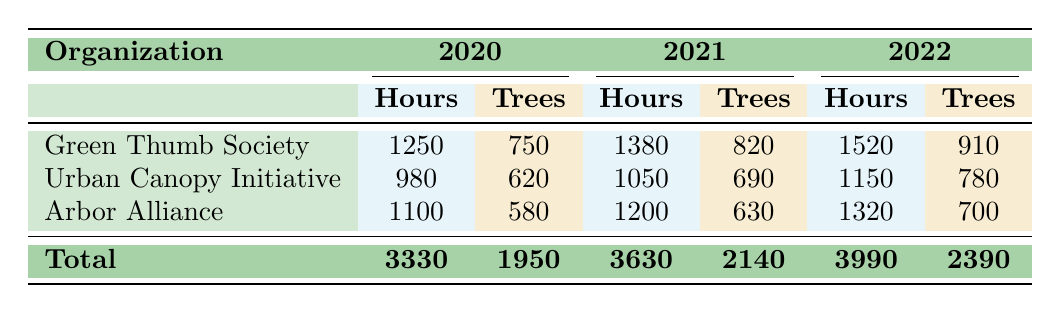What was the total number of volunteer hours recorded in 2020? By adding the volunteer hours from each organization in 2020: Green Thumb Society (1250) + Urban Canopy Initiative (980) + Arbor Alliance (1100) = 3330 hours.
Answer: 3330 How many trees were planted by the Urban Canopy Initiative in 2021? The table shows that the Urban Canopy Initiative planted 690 trees in 2021.
Answer: 690 Which organization had the highest number of volunteer hours in 2022? Green Thumb Society had 1520 volunteer hours in 2022, which is higher than Urban Canopy Initiative (1150) and Arbor Alliance (1320).
Answer: Green Thumb Society What is the average number of trees planted per organization in 2020? In 2020, there were three organizations (Green Thumb Society, Urban Canopy Initiative, Arbor Alliance) that planted a total of 1950 trees. To find the average, divide 1950 by 3, which equals 650.
Answer: 650 Did the Arbor Alliance increase or decrease the number of trees planted from 2020 to 2022? In 2020, Arbor Alliance planted 580 trees and in 2022, they planted 700 trees, indicating an increase.
Answer: Increase What is the total number of trees planted by all organizations in 2021? To find the total for 2021, add the trees planted by each organization: Green Thumb Society (820) + Urban Canopy Initiative (690) + Arbor Alliance (630) = 2140 trees.
Answer: 2140 Was the total number of volunteer hours in 2021 greater than in 2020? The total volunteer hours in 2021 was 3630, whereas in 2020 it was 3330, indicating that it was indeed greater.
Answer: Yes Which organization consistently increased its total volunteer hours over the three years? Green Thumb Society showed increased hours each year: 1250 in 2020, 1380 in 2021, and 1520 in 2022.
Answer: Green Thumb Society 